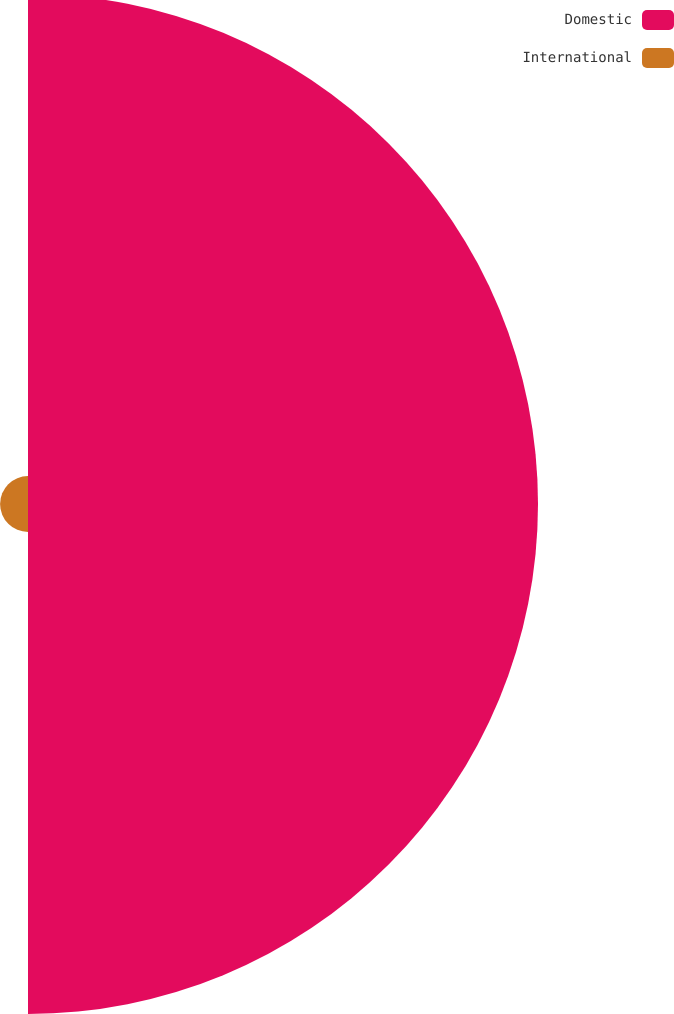<chart> <loc_0><loc_0><loc_500><loc_500><pie_chart><fcel>Domestic<fcel>International<nl><fcel>94.81%<fcel>5.19%<nl></chart> 